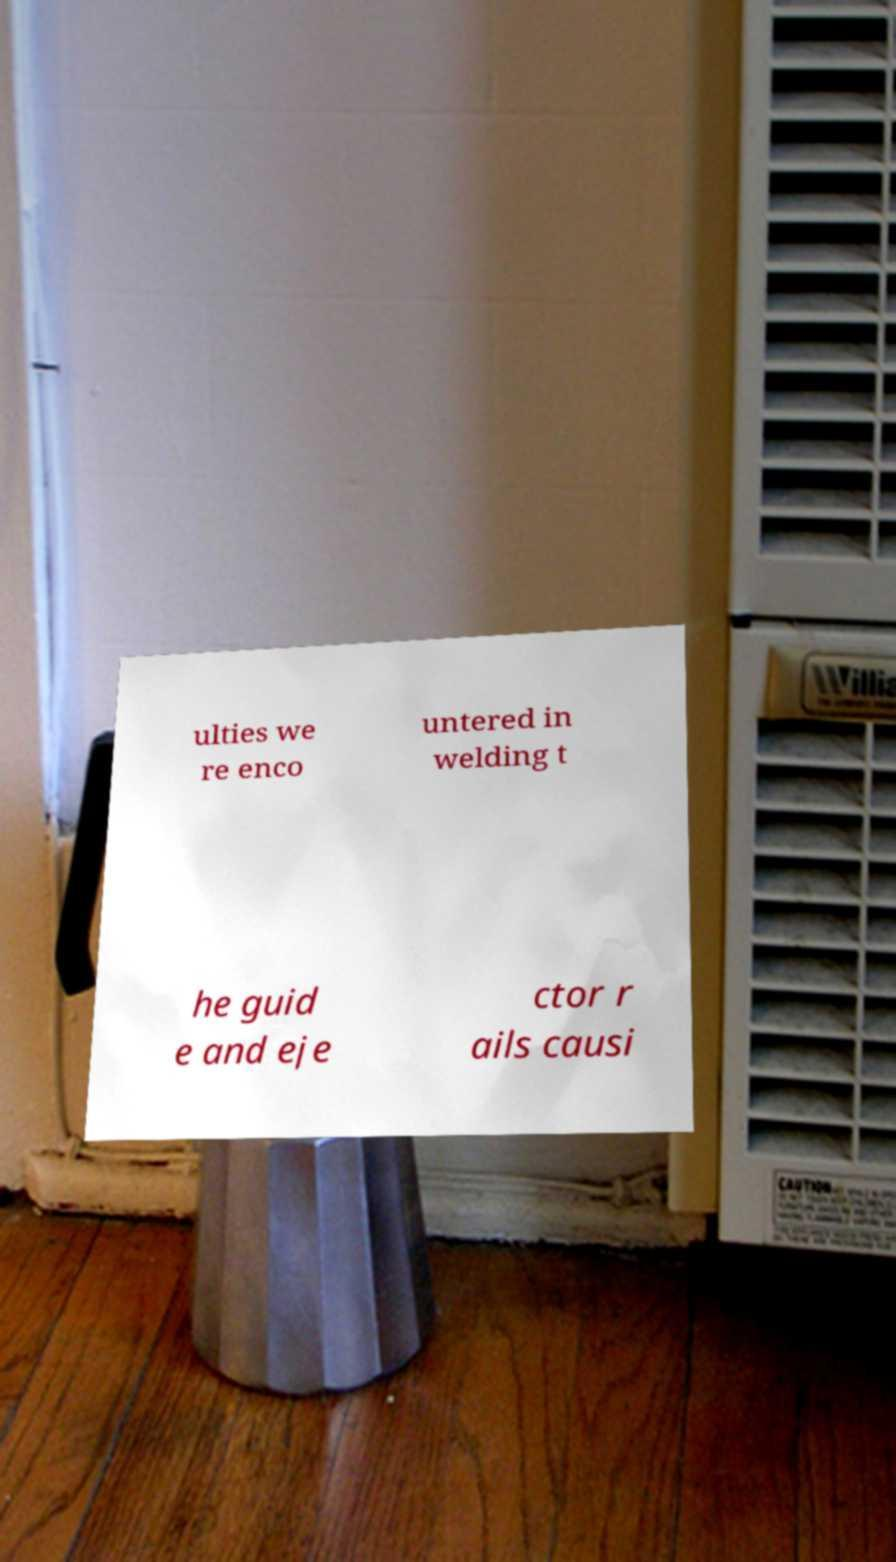Can you read and provide the text displayed in the image?This photo seems to have some interesting text. Can you extract and type it out for me? ulties we re enco untered in welding t he guid e and eje ctor r ails causi 